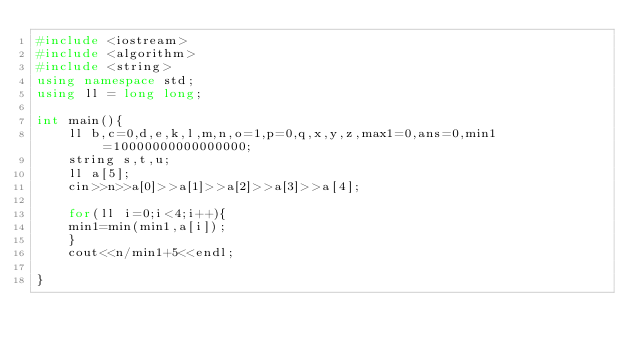Convert code to text. <code><loc_0><loc_0><loc_500><loc_500><_C++_>#include <iostream>
#include <algorithm>
#include <string>
using namespace std;
using ll = long long;

int main(){
    ll b,c=0,d,e,k,l,m,n,o=1,p=0,q,x,y,z,max1=0,ans=0,min1=10000000000000000;
    string s,t,u;
    ll a[5];
    cin>>n>>a[0]>>a[1]>>a[2]>>a[3]>>a[4];
   
    for(ll i=0;i<4;i++){
    min1=min(min1,a[i]);
    }
    cout<<n/min1+5<<endl;
    
}




</code> 